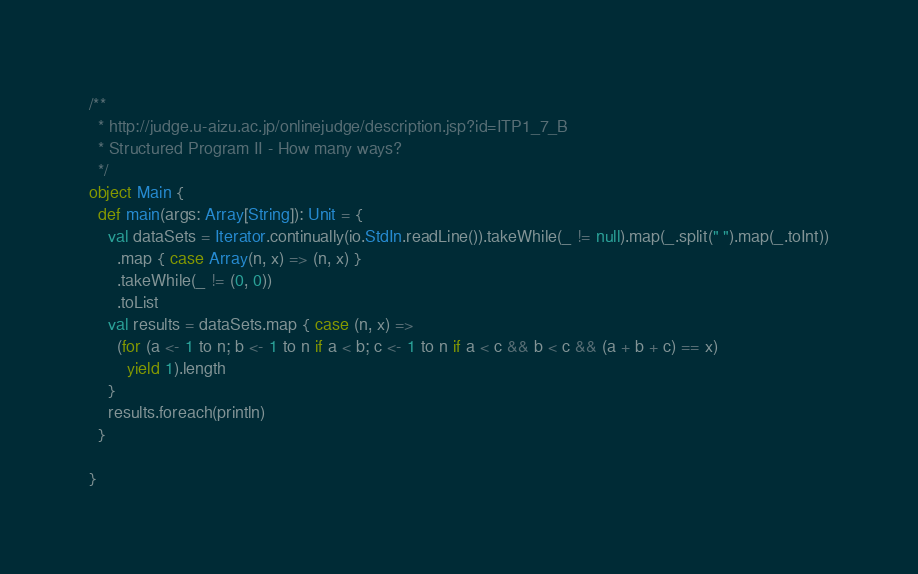Convert code to text. <code><loc_0><loc_0><loc_500><loc_500><_Scala_>/**
  * http://judge.u-aizu.ac.jp/onlinejudge/description.jsp?id=ITP1_7_B
  * Structured Program II - How many ways?
  */
object Main {
  def main(args: Array[String]): Unit = {
    val dataSets = Iterator.continually(io.StdIn.readLine()).takeWhile(_ != null).map(_.split(" ").map(_.toInt))
      .map { case Array(n, x) => (n, x) }
      .takeWhile(_ != (0, 0))
      .toList
    val results = dataSets.map { case (n, x) =>
      (for (a <- 1 to n; b <- 1 to n if a < b; c <- 1 to n if a < c && b < c && (a + b + c) == x)
        yield 1).length
    }
    results.foreach(println)
  }

}</code> 